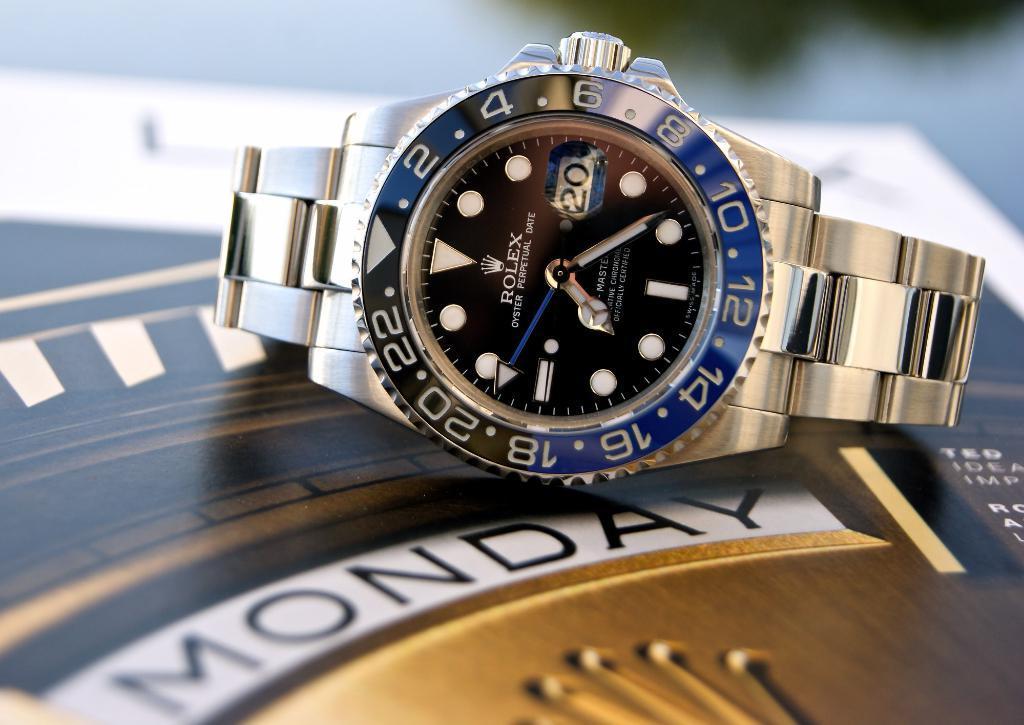How would you summarize this image in a sentence or two? In the image we can see the wrist watch, poster and the background is blurred. 